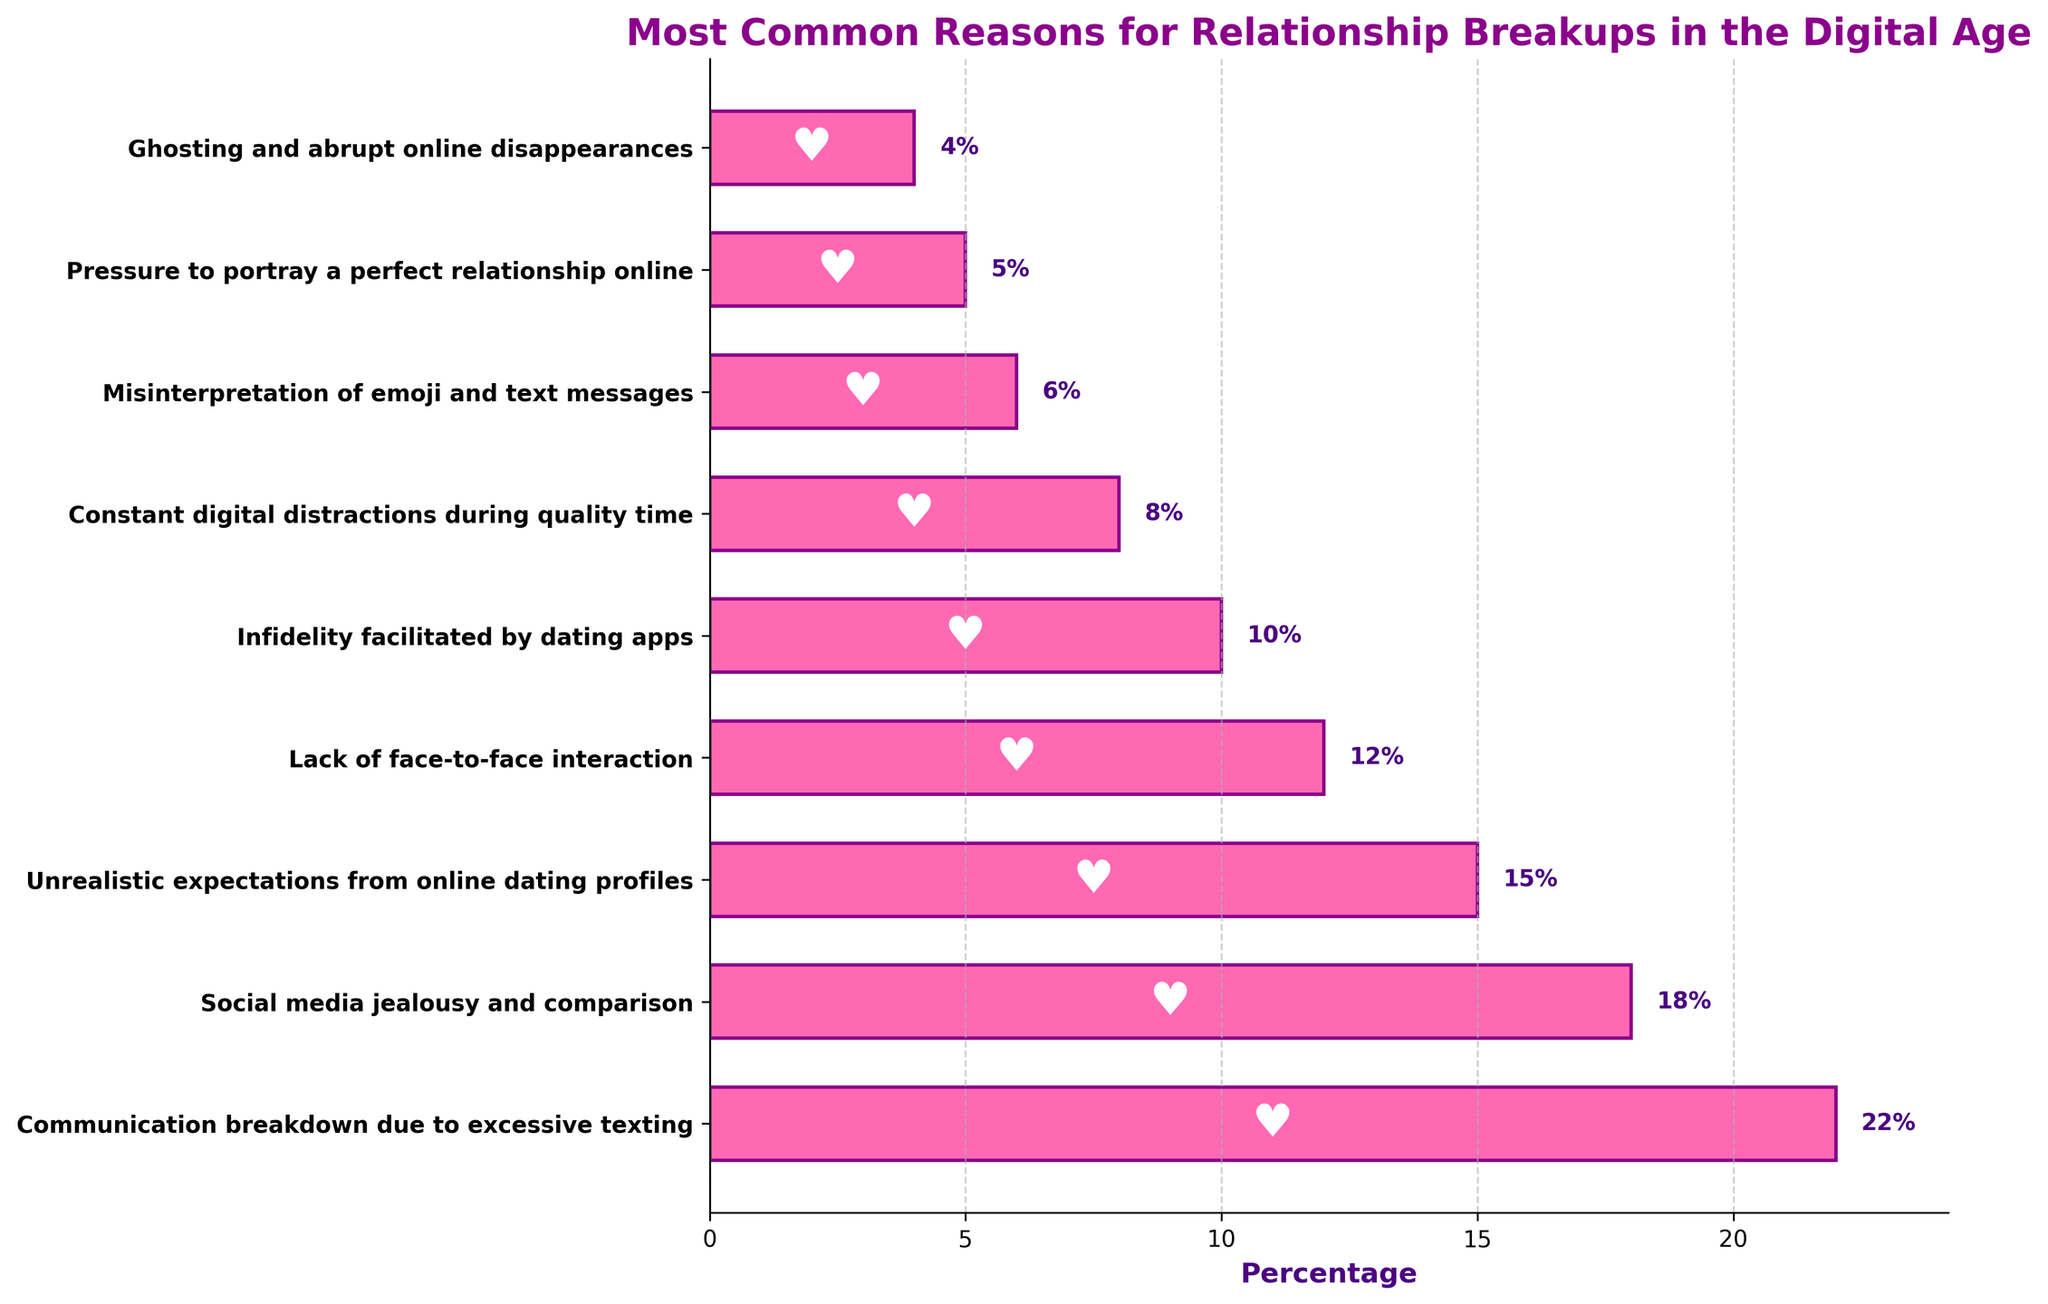what is the most common reason for relationship breakups in the digital age? The figure shows percentages for various reasons. The highest percentage corresponds to "Communication breakdown due to excessive texting" at 22%.
Answer: Communication breakdown due to excessive texting How much higher is the percentage for "Communication breakdown due to excessive texting" compared to "Infidelity facilitated by dating apps"? The percentage for "Communication breakdown due to excessive texting" is 22%, and for "Infidelity facilitated by dating apps," it is 10%. The difference is 22% - 10% = 12%.
Answer: 12% What is the combined percentage for reasons related to social media ("Social media jealousy and comparison" and "Pressure to portray a perfect relationship online")? The percentages are 18% for "Social media jealousy and comparison" and 5% for "Pressure to portray a perfect relationship online." The combined percentage is 18% + 5% = 23%.
Answer: 23% Which problem related to digital communication has a higher occurrence: "Misinterpretation of emoji and text messages" or "Ghosting and abrupt online disappearances"? The percentage for "Misinterpretation of emoji and text messages" is 6%, while for "Ghosting and abrupt online disappearances," it is 4%. Thus, "Misinterpretation of emoji and text messages" has a higher occurrence.
Answer: Misinterpretation of emoji and text messages What is the average percentage for the top three reasons for breakups? The percentages for the top three reasons are 22%, 18%, and 15%. The average is calculated as (22 + 18 + 15) / 3 = 55 / 3 ≈ 18.33%.
Answer: 18.33% How do the percentages for "Lack of face-to-face interaction" and "Constant digital distractions during quality time" compare? The percentage for "Lack of face-to-face interaction" is 12%, whereas for "Constant digital distractions during quality time," it is 8%. Thus, "Lack of face-to-face interaction" is higher by 4%.
Answer: 4% Which reason is depicted at the bottom of the chart, and what is its percentage? The chart depicts "Ghosting and abrupt online disappearances" at the bottom with a percentage of 4%.
Answer: Ghosting and abrupt online disappearances, 4% What is the cumulative percentage of the three least common reasons for relationship breakups? The percentages for the three least common reasons— "Pressure to portray a perfect relationship online" (5%), "Ghosting and abrupt online disappearances" (4%), and "Misinterpretation of emoji and text messages" (6%)— add up to 5% + 4% + 6% = 15%.
Answer: 15% How much greater is the occurrence of "Unrealistic expectations from online dating profiles" than "Lack of face-to-face interaction"? The percentage for "Unrealistic expectations from online dating profiles" is 15%, and for "Lack of face-to-face interaction," it is 12%. The difference is 15% - 12% = 3%.
Answer: 3% 